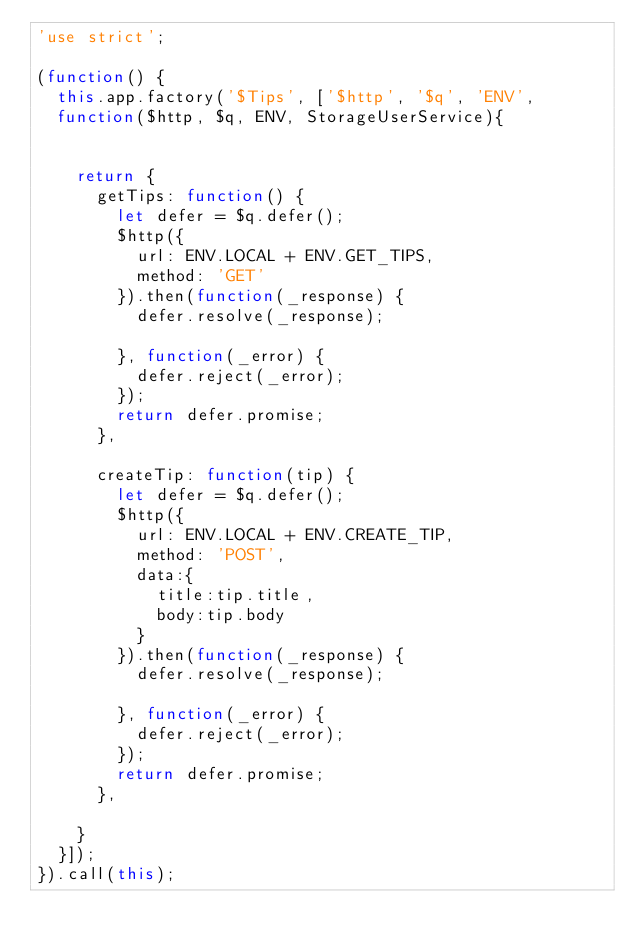Convert code to text. <code><loc_0><loc_0><loc_500><loc_500><_JavaScript_>'use strict';

(function() {
  this.app.factory('$Tips', ['$http', '$q', 'ENV',
  function($http, $q, ENV, StorageUserService){


    return {
      getTips: function() {
        let defer = $q.defer();
        $http({
          url: ENV.LOCAL + ENV.GET_TIPS,
          method: 'GET'
        }).then(function(_response) {
          defer.resolve(_response);

        }, function(_error) {
          defer.reject(_error);
        });
        return defer.promise;
      },

      createTip: function(tip) {
        let defer = $q.defer();
        $http({
          url: ENV.LOCAL + ENV.CREATE_TIP,
          method: 'POST',
          data:{
            title:tip.title,
            body:tip.body
          }
        }).then(function(_response) {
          defer.resolve(_response);

        }, function(_error) {
          defer.reject(_error);
        });
        return defer.promise;
      },

    }
  }]);
}).call(this);
</code> 